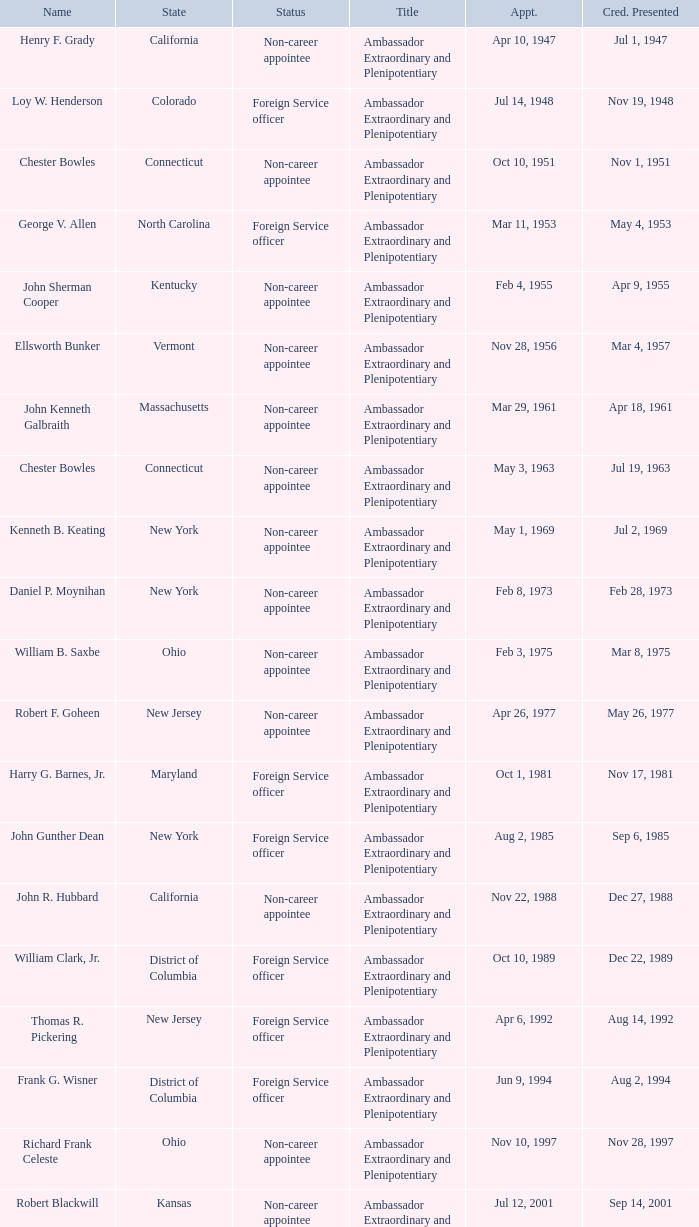What day was the appointment when Credentials Presented was jul 2, 1969? May 1, 1969. 